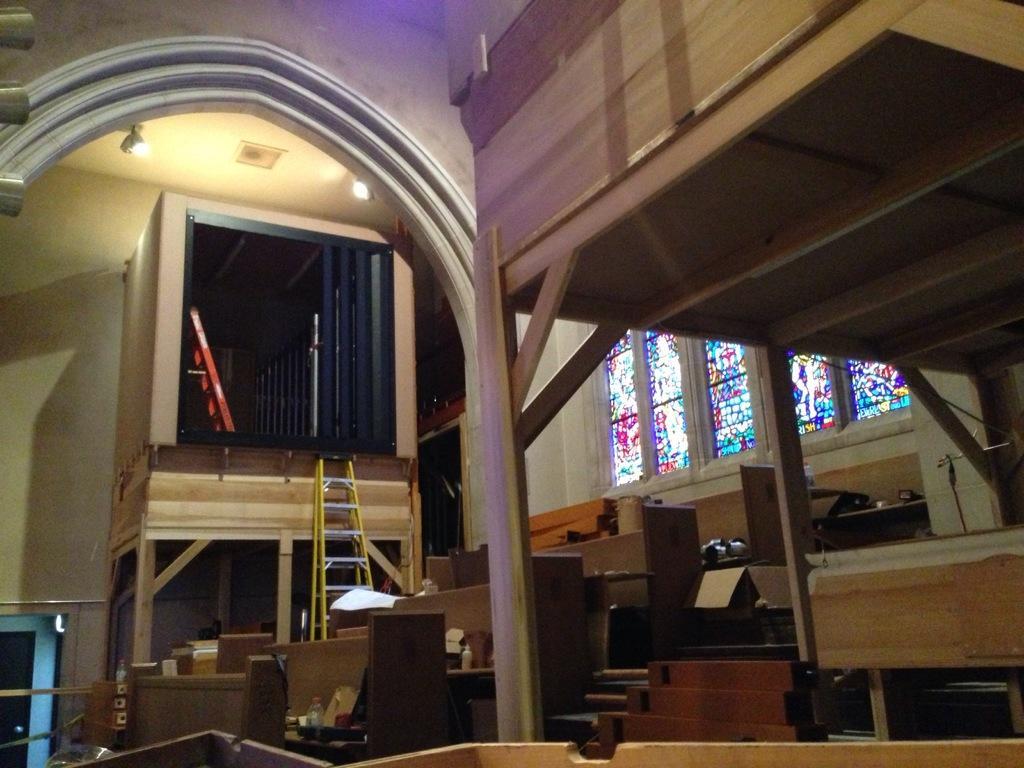How would you summarize this image in a sentence or two? In this image, we can see the interior view of a room. We can see some desks with objects. We can see some stairs and ladders. We can see some wood. We can see some windows with glasses. We can see the arch and the roof with some lights. We can see a blue colored object in the bottom left corner. 